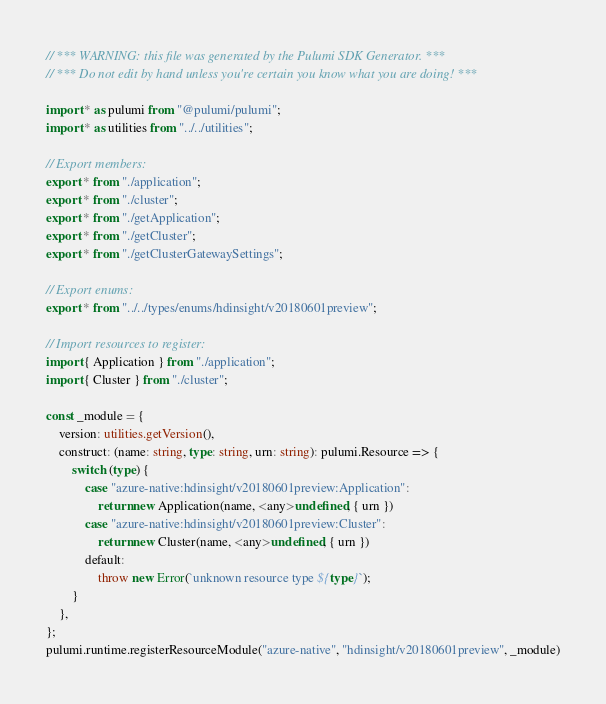Convert code to text. <code><loc_0><loc_0><loc_500><loc_500><_TypeScript_>// *** WARNING: this file was generated by the Pulumi SDK Generator. ***
// *** Do not edit by hand unless you're certain you know what you are doing! ***

import * as pulumi from "@pulumi/pulumi";
import * as utilities from "../../utilities";

// Export members:
export * from "./application";
export * from "./cluster";
export * from "./getApplication";
export * from "./getCluster";
export * from "./getClusterGatewaySettings";

// Export enums:
export * from "../../types/enums/hdinsight/v20180601preview";

// Import resources to register:
import { Application } from "./application";
import { Cluster } from "./cluster";

const _module = {
    version: utilities.getVersion(),
    construct: (name: string, type: string, urn: string): pulumi.Resource => {
        switch (type) {
            case "azure-native:hdinsight/v20180601preview:Application":
                return new Application(name, <any>undefined, { urn })
            case "azure-native:hdinsight/v20180601preview:Cluster":
                return new Cluster(name, <any>undefined, { urn })
            default:
                throw new Error(`unknown resource type ${type}`);
        }
    },
};
pulumi.runtime.registerResourceModule("azure-native", "hdinsight/v20180601preview", _module)
</code> 